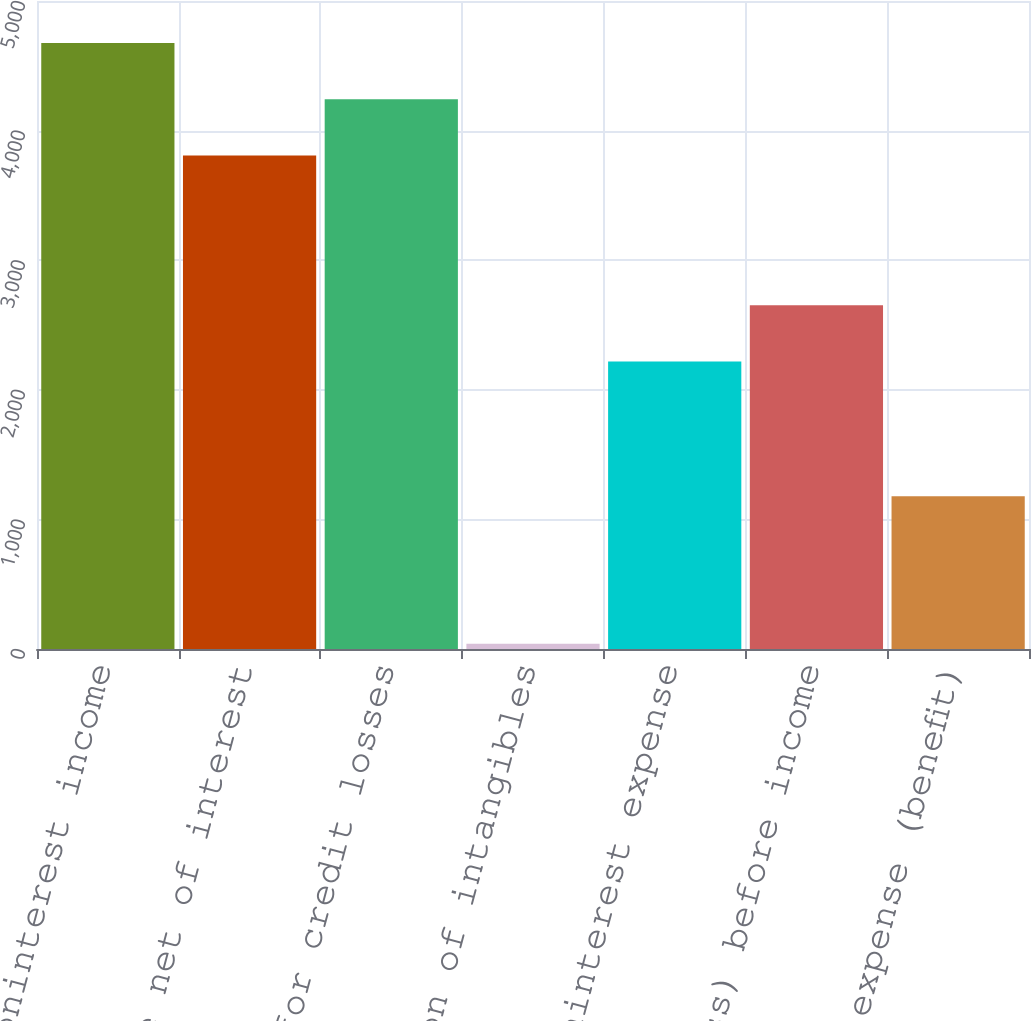Convert chart. <chart><loc_0><loc_0><loc_500><loc_500><bar_chart><fcel>Noninterest income<fcel>Total revenue net of interest<fcel>Provision for credit losses<fcel>Amortization of intangibles<fcel>Other noninterest expense<fcel>Income (loss) before income<fcel>Income tax expense (benefit)<nl><fcel>4676.6<fcel>3808<fcel>4242.3<fcel>40<fcel>2219<fcel>2653.3<fcel>1178<nl></chart> 